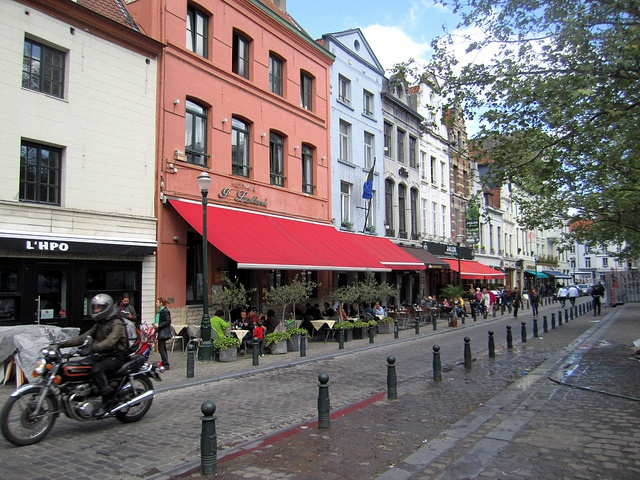Describe the objects in this image and their specific colors. I can see motorcycle in darkgray, black, gray, and white tones, people in darkgray, black, gray, and maroon tones, people in darkgray, black, and gray tones, potted plant in darkgray, gray, black, and darkgreen tones, and people in darkgray, black, gray, brown, and maroon tones in this image. 